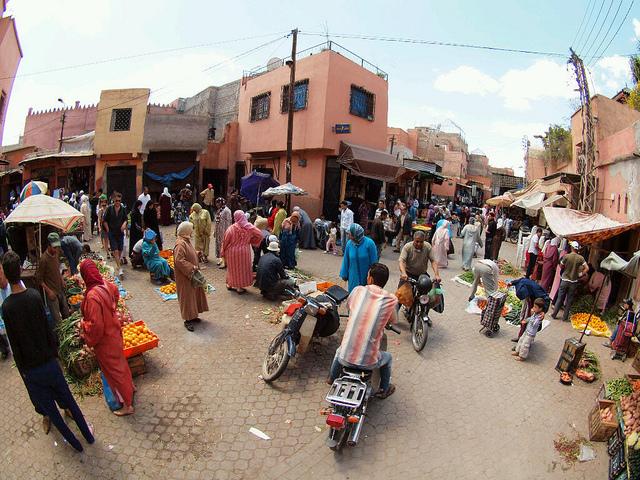Is this a carnival?
Short answer required. No. Where is this?
Answer briefly. Market. Is this an open market?
Give a very brief answer. Yes. What is he carrying on his scooter?
Write a very short answer. Fruit. 